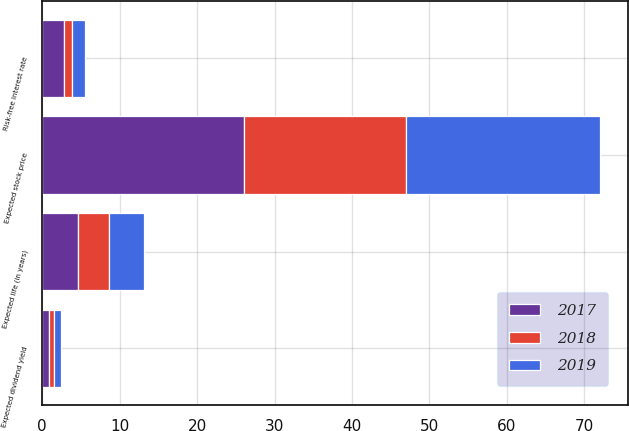Convert chart to OTSL. <chart><loc_0><loc_0><loc_500><loc_500><stacked_bar_chart><ecel><fcel>Expected stock price<fcel>Expected dividend yield<fcel>Risk-free interest rate<fcel>Expected life (in years)<nl><fcel>2017<fcel>26<fcel>0.9<fcel>2.8<fcel>4.6<nl><fcel>2019<fcel>25<fcel>0.8<fcel>1.7<fcel>4.5<nl><fcel>2018<fcel>21<fcel>0.7<fcel>1.1<fcel>4<nl></chart> 